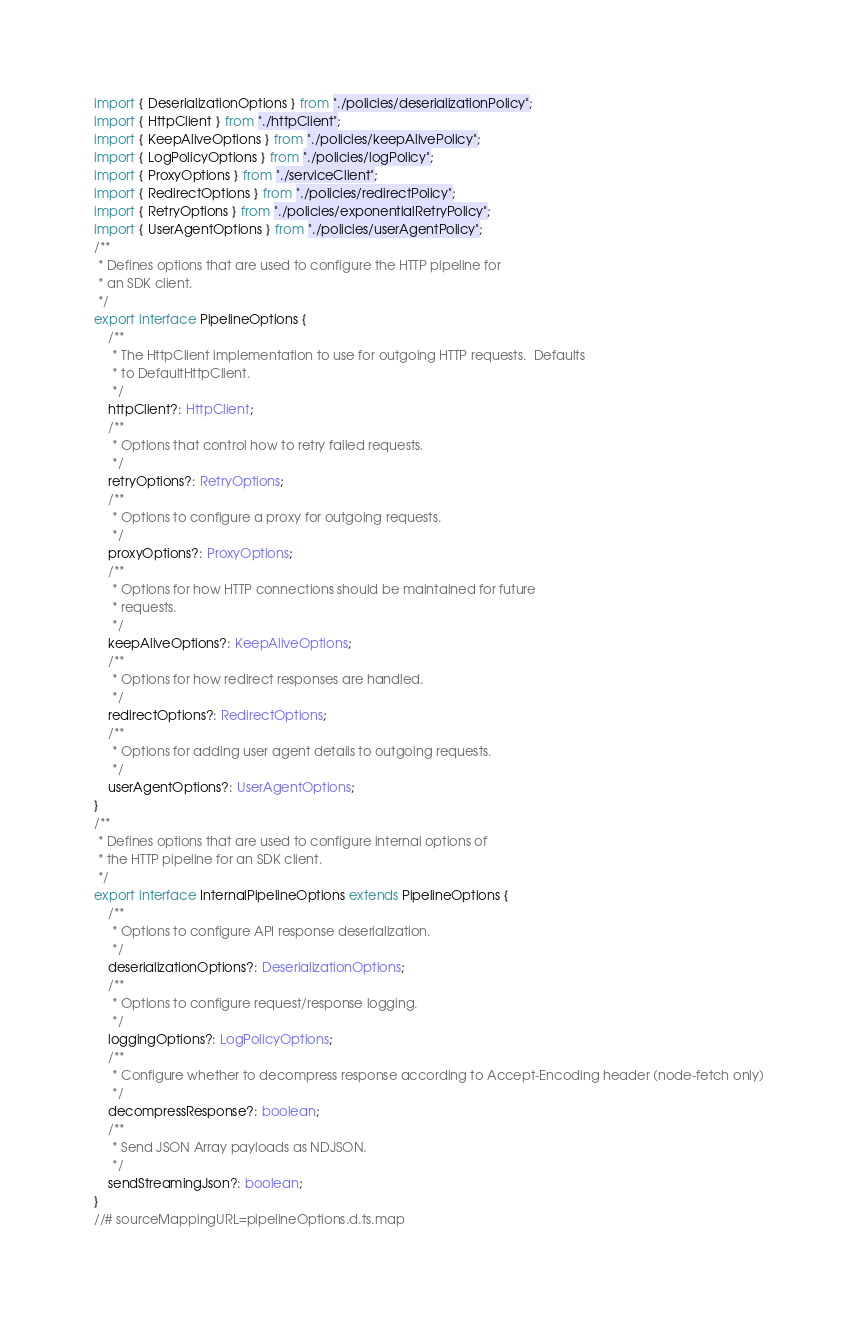<code> <loc_0><loc_0><loc_500><loc_500><_TypeScript_>import { DeserializationOptions } from "./policies/deserializationPolicy";
import { HttpClient } from "./httpClient";
import { KeepAliveOptions } from "./policies/keepAlivePolicy";
import { LogPolicyOptions } from "./policies/logPolicy";
import { ProxyOptions } from "./serviceClient";
import { RedirectOptions } from "./policies/redirectPolicy";
import { RetryOptions } from "./policies/exponentialRetryPolicy";
import { UserAgentOptions } from "./policies/userAgentPolicy";
/**
 * Defines options that are used to configure the HTTP pipeline for
 * an SDK client.
 */
export interface PipelineOptions {
    /**
     * The HttpClient implementation to use for outgoing HTTP requests.  Defaults
     * to DefaultHttpClient.
     */
    httpClient?: HttpClient;
    /**
     * Options that control how to retry failed requests.
     */
    retryOptions?: RetryOptions;
    /**
     * Options to configure a proxy for outgoing requests.
     */
    proxyOptions?: ProxyOptions;
    /**
     * Options for how HTTP connections should be maintained for future
     * requests.
     */
    keepAliveOptions?: KeepAliveOptions;
    /**
     * Options for how redirect responses are handled.
     */
    redirectOptions?: RedirectOptions;
    /**
     * Options for adding user agent details to outgoing requests.
     */
    userAgentOptions?: UserAgentOptions;
}
/**
 * Defines options that are used to configure internal options of
 * the HTTP pipeline for an SDK client.
 */
export interface InternalPipelineOptions extends PipelineOptions {
    /**
     * Options to configure API response deserialization.
     */
    deserializationOptions?: DeserializationOptions;
    /**
     * Options to configure request/response logging.
     */
    loggingOptions?: LogPolicyOptions;
    /**
     * Configure whether to decompress response according to Accept-Encoding header (node-fetch only)
     */
    decompressResponse?: boolean;
    /**
     * Send JSON Array payloads as NDJSON.
     */
    sendStreamingJson?: boolean;
}
//# sourceMappingURL=pipelineOptions.d.ts.map</code> 